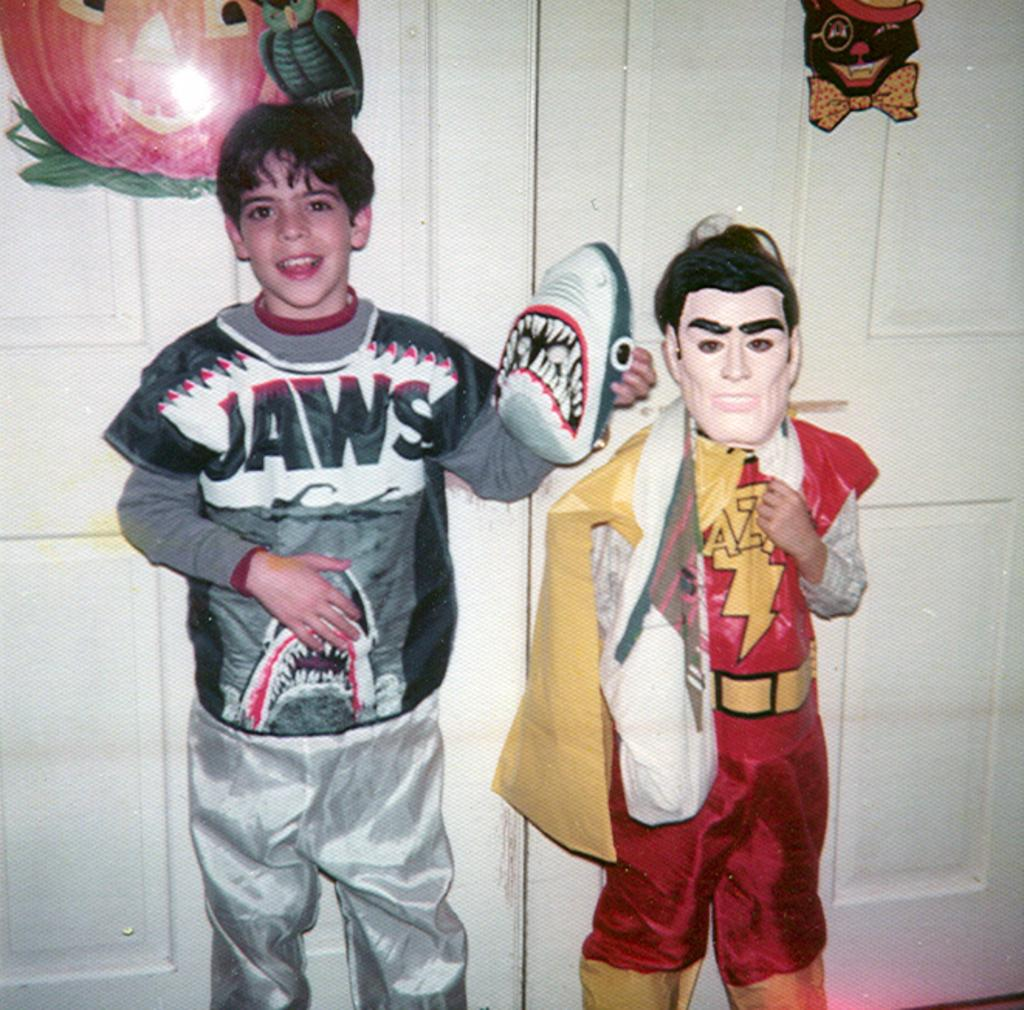Provide a one-sentence caption for the provided image. the word jaws is on the shirt of a person. 